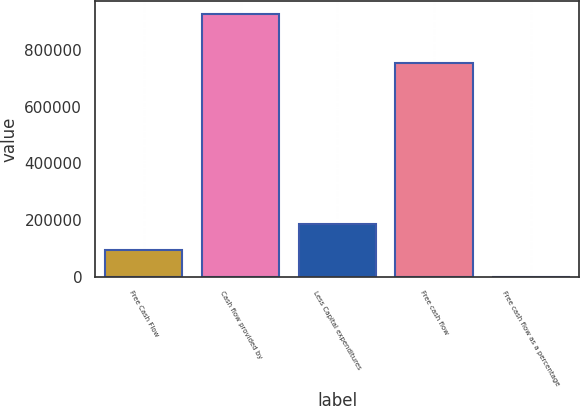Convert chart to OTSL. <chart><loc_0><loc_0><loc_500><loc_500><bar_chart><fcel>Free Cash Flow<fcel>Cash flow provided by<fcel>Less Capital expenditures<fcel>Free cash flow<fcel>Free cash flow as a percentage<nl><fcel>92778.6<fcel>927693<fcel>185547<fcel>754040<fcel>10.3<nl></chart> 